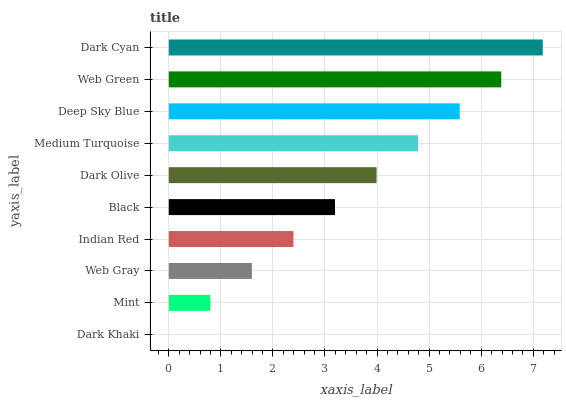Is Dark Khaki the minimum?
Answer yes or no. Yes. Is Dark Cyan the maximum?
Answer yes or no. Yes. Is Mint the minimum?
Answer yes or no. No. Is Mint the maximum?
Answer yes or no. No. Is Mint greater than Dark Khaki?
Answer yes or no. Yes. Is Dark Khaki less than Mint?
Answer yes or no. Yes. Is Dark Khaki greater than Mint?
Answer yes or no. No. Is Mint less than Dark Khaki?
Answer yes or no. No. Is Dark Olive the high median?
Answer yes or no. Yes. Is Black the low median?
Answer yes or no. Yes. Is Black the high median?
Answer yes or no. No. Is Deep Sky Blue the low median?
Answer yes or no. No. 